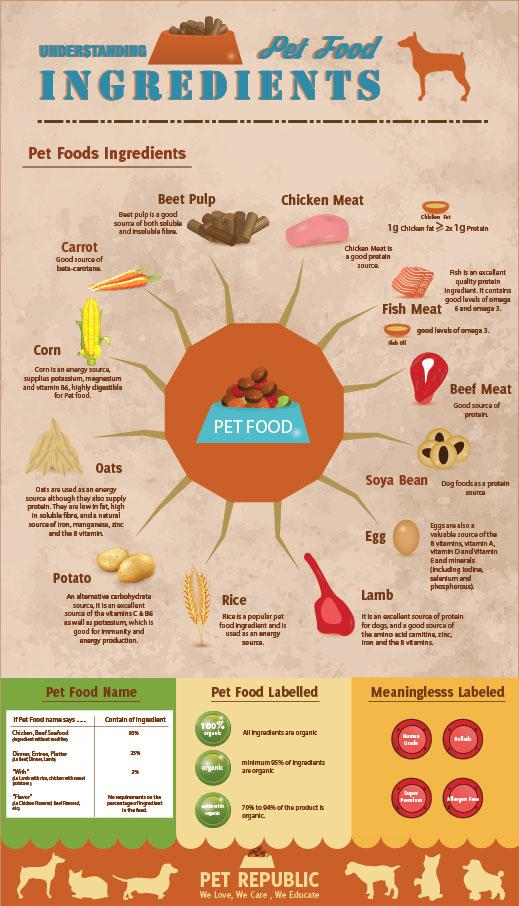Mention a couple of crucial points in this snapshot. Soybean is considered a valuable protein source for pets, providing essential amino acids to support their health and well-being. Beet pulp is considered a good source of both soluble and insoluble fiber. Fish oil is a popular choice among pet owners because it provides optimal levels of omega-3 fatty acids in pet foods. Our research has concluded that egg pet food is a valuable source of B vitamins, Vitamin A,D,E and minerals. Rice is a common ingredient in pet food that serves as a source of energy for pets. 